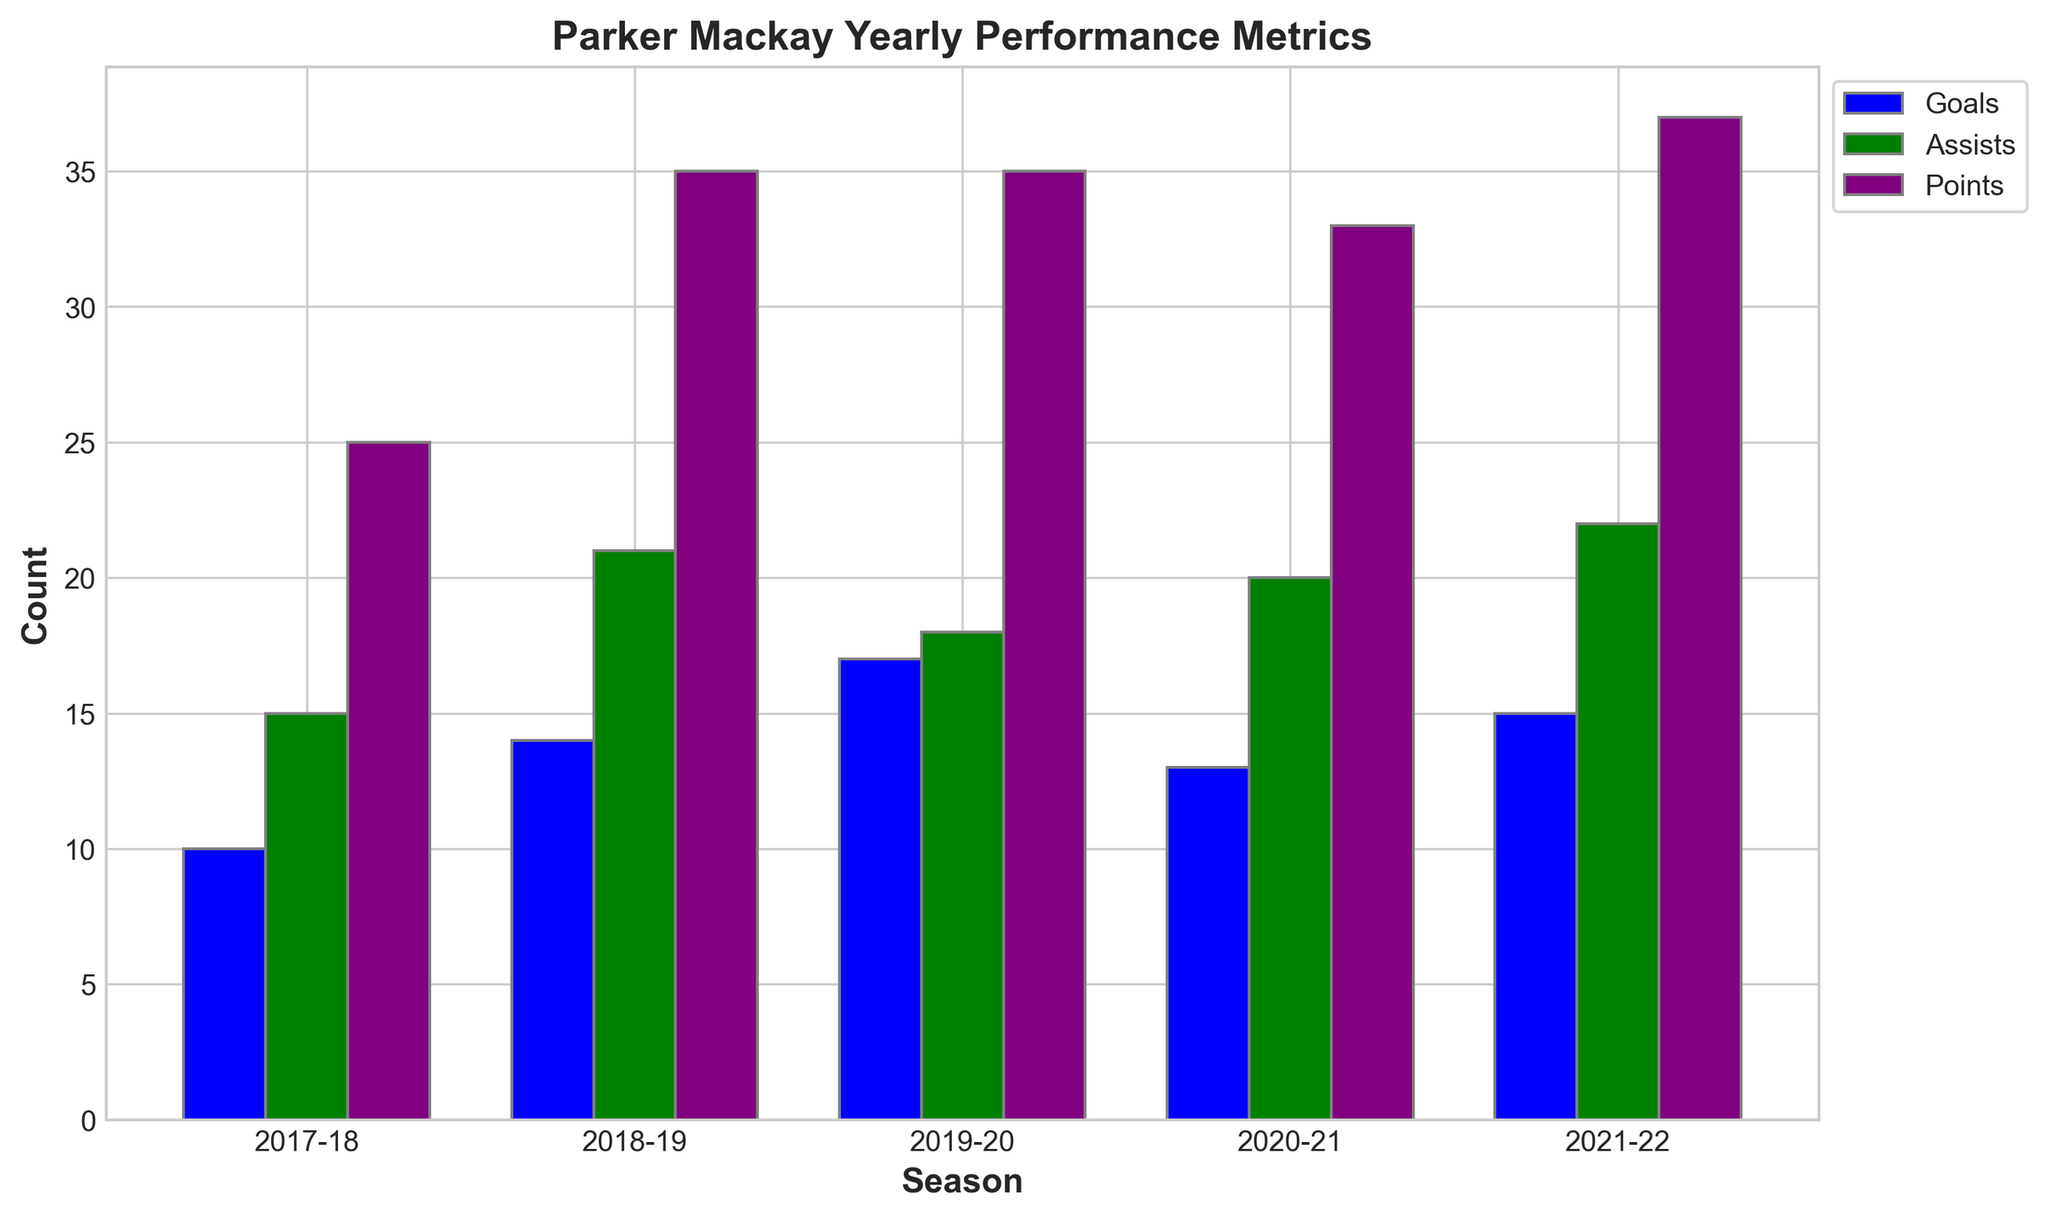Which season did Parker Mackay score the most goals? Parker scored the most goals in the 2019-20 season, as seen from the tallest blue bar in the goals category.
Answer: 2019-20 What's the total number of assists Parker Mackay made in the 2018-19 and 2021-22 seasons combined? Parker made 21 assists in 2018-19 and 22 assists in 2021-22. Adding them gives 21 + 22 = 43.
Answer: 43 Which season had the least combined number of goals and assists? 2017-18 has 10 goals and 15 assists, 2018-19 has 14 goals and 21 assists, 2019-20 has 17 goals and 18 assists, 2020-21 has 13 goals and 20 assists, and 2021-22 has 15 goals and 22 assists. Thus, 2017-18 has the least combined, with 10 + 15 = 25.
Answer: 2017-18 Between which consecutive seasons did Parker Mackay's points remain the same? Parker's points in 2018-19 and 2019-20 are both 35, as indicated by the equal height of the purple bars for these seasons.
Answer: 2018-19 and 2019-20 What is the average number of points Parker Mackay scored per season from 2017-18 to 2021-22? The number of points for each season is 25, 35, 35, 33, and 37. The average is calculated as (25 + 35 + 35 + 33 + 37) / 5 = 33.
Answer: 33 Which season had the highest points, and how many did he score that season? The tallest purple bar indicates the season with the highest points. The highest is 37 points in the 2021-22 season.
Answer: 2021-22, 37 How many more assists did Parker make in 2021-22 compared to 2017-18? Parker made 22 assists in 2021-22 and 15 assists in 2017-18. The difference is 22 - 15 = 7.
Answer: 7 What is the difference in goals between the seasons 2019-20 and 2020-21? Parker scored 17 goals in 2019-20 and 13 goals in 2020-21. The difference is 17 - 13 = 4.
Answer: 4 If we sum the highest number of goals, assists, and points Parker achieved in any season, what total do we get? The highest number of goals is 17 (2019-20), the highest number of assists is 22 (2021-22), and the highest number of points is 37 (2021-22). The sum is 17 + 22 + 37 = 76.
Answer: 76 